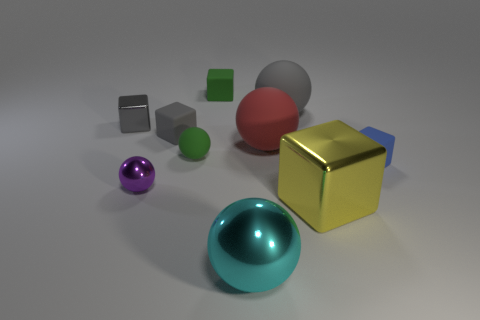What is the shape of the tiny rubber thing that is the same color as the tiny metal block?
Ensure brevity in your answer.  Cube. How many other objects are there of the same color as the small matte ball?
Offer a very short reply. 1. What is the material of the sphere that is on the left side of the green sphere that is on the left side of the cyan sphere?
Your response must be concise. Metal. There is a gray sphere that is the same size as the yellow object; what is its material?
Keep it short and to the point. Rubber. There is a shiny object that is behind the blue block; is its size the same as the yellow thing?
Give a very brief answer. No. Is the shape of the large metal thing that is on the left side of the large yellow block the same as  the large yellow object?
Provide a short and direct response. No. What number of things are either large shiny balls or matte blocks left of the blue block?
Your answer should be very brief. 3. Are there fewer green matte things than cubes?
Provide a short and direct response. Yes. Is the number of large cyan cylinders greater than the number of large metal spheres?
Provide a short and direct response. No. How many other things are the same material as the big block?
Your answer should be very brief. 3. 